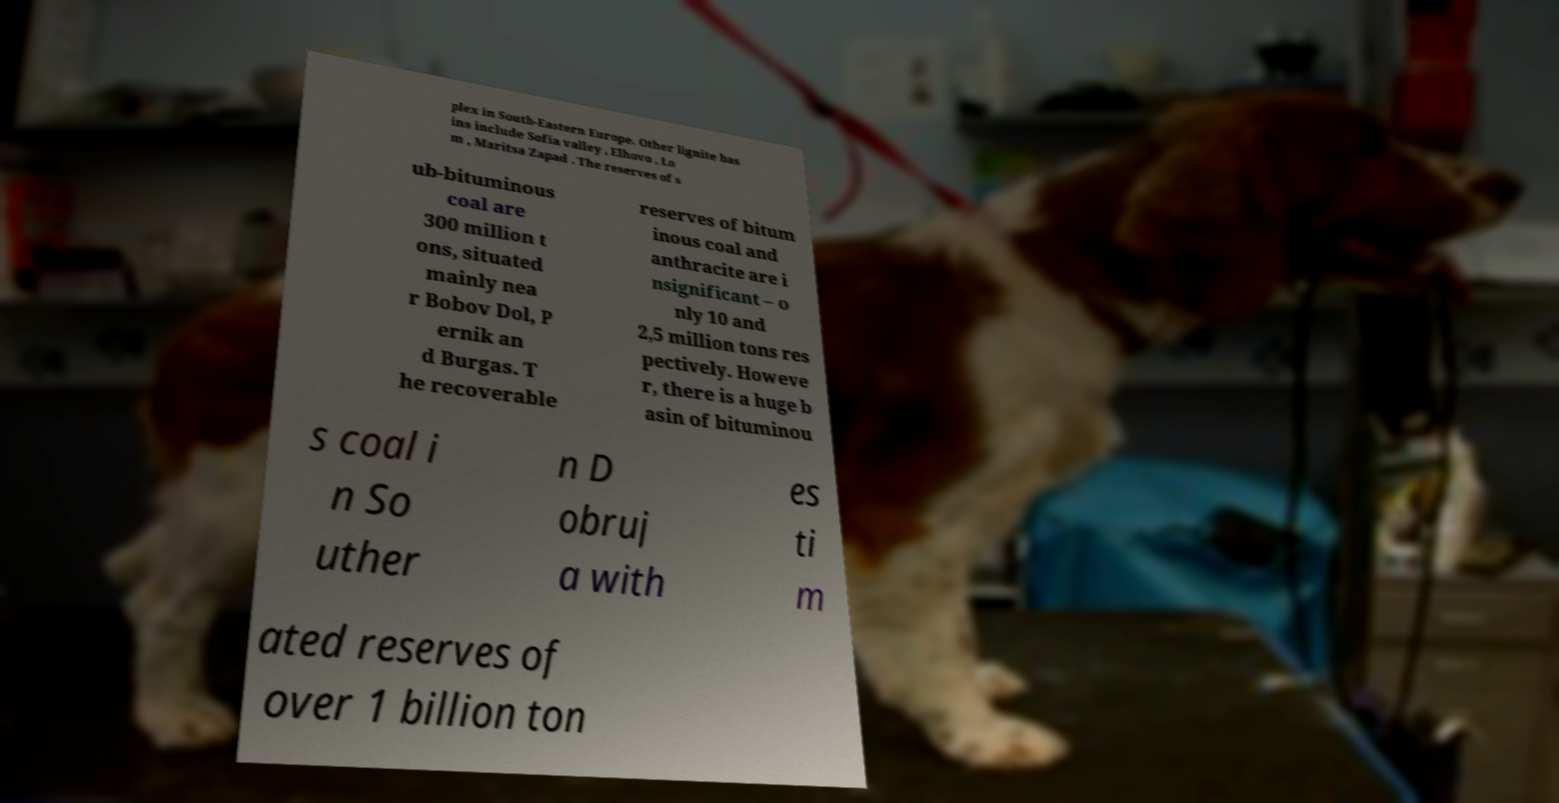Could you assist in decoding the text presented in this image and type it out clearly? plex in South-Eastern Europe. Other lignite bas ins include Sofia valley , Elhovo , Lo m , Maritsa Zapad . The reserves of s ub-bituminous coal are 300 million t ons, situated mainly nea r Bobov Dol, P ernik an d Burgas. T he recoverable reserves of bitum inous coal and anthracite are i nsignificant – o nly 10 and 2,5 million tons res pectively. Howeve r, there is a huge b asin of bituminou s coal i n So uther n D obruj a with es ti m ated reserves of over 1 billion ton 